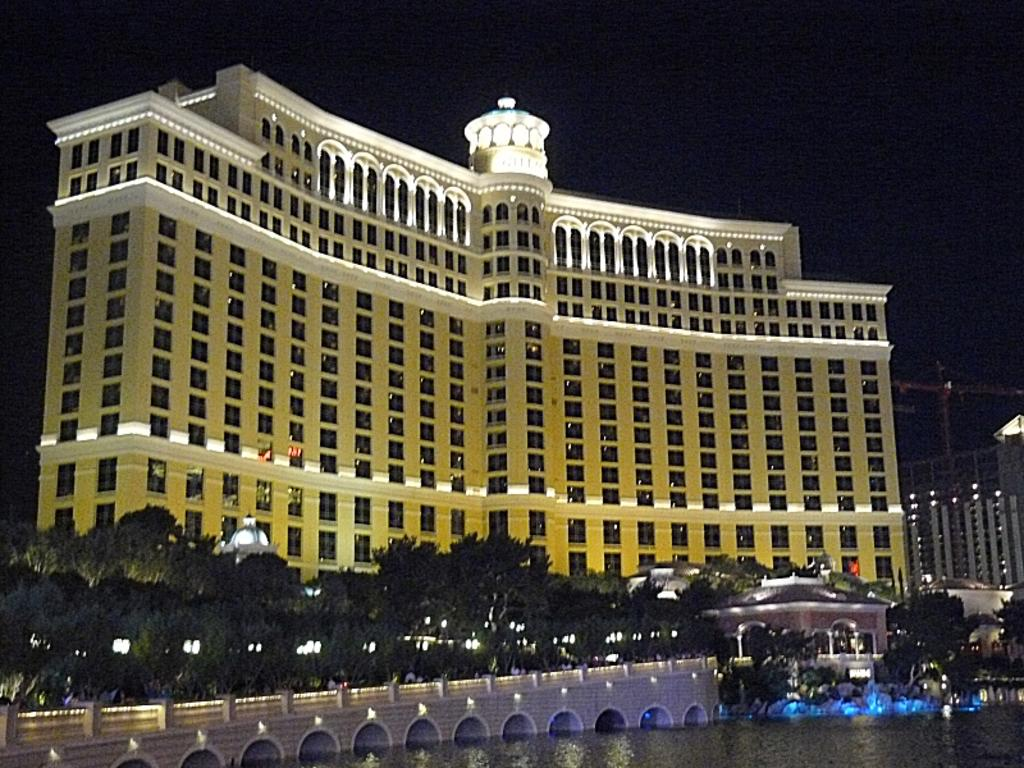What is located at the front of the image? There is water in the front of the image. What structure can be seen in the center of the image? There is a bridge in the center of the image. What type of vegetation is present in the image? There are trees in the image. What can be seen in the background of the image? There are buildings in the background of the image. What type of afterthought is depicted in the image? There is no afterthought present in the image; it features water, a bridge, trees, and buildings. How many bites can be seen being taken out of the bridge in the image? There are no bites taken out of the bridge in the image; it is a solid structure. 